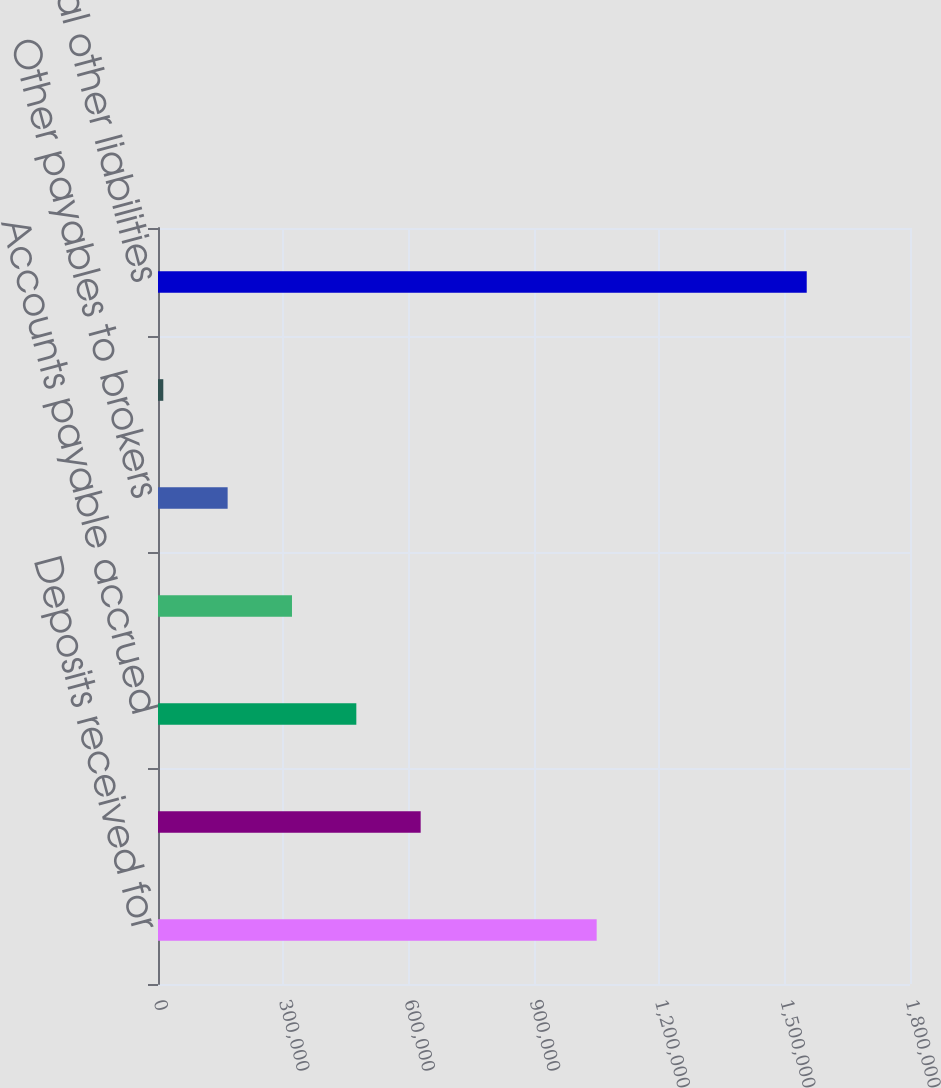Convert chart to OTSL. <chart><loc_0><loc_0><loc_500><loc_500><bar_chart><fcel>Deposits received for<fcel>Derivative liabilities<fcel>Accounts payable accrued<fcel>Income tax-related liabilities<fcel>Other payables to brokers<fcel>Subserviced loan advances<fcel>Total other liabilities<nl><fcel>1.05001e+06<fcel>628728<fcel>474715<fcel>320702<fcel>166689<fcel>12676<fcel>1.55281e+06<nl></chart> 